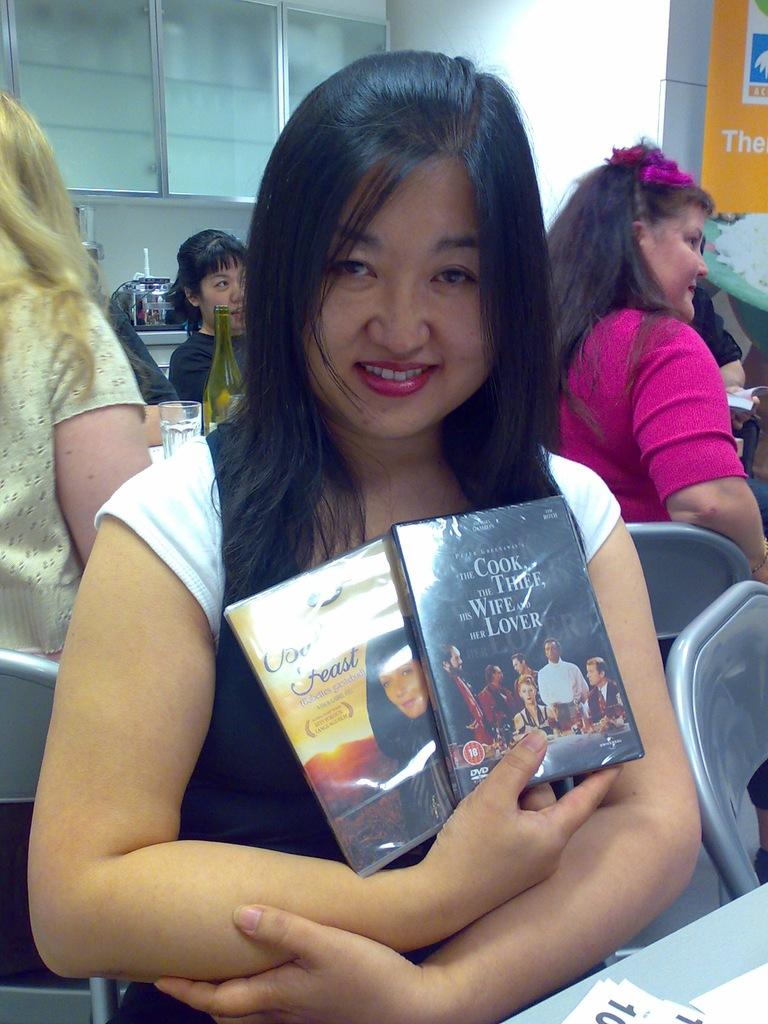What is the name of the dvd on the right?
Your answer should be compact. The cook, the thief, his wife and her lover. 